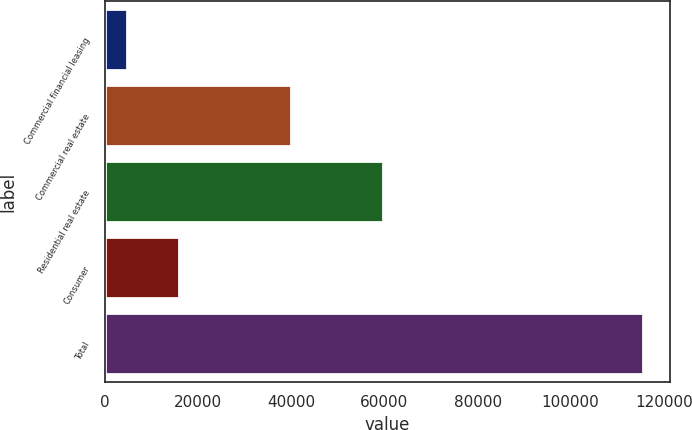Convert chart to OTSL. <chart><loc_0><loc_0><loc_500><loc_500><bar_chart><fcel>Commercial financial leasing<fcel>Commercial real estate<fcel>Residential real estate<fcel>Consumer<fcel>Total<nl><fcel>4794<fcel>39867<fcel>59657<fcel>15873.9<fcel>115593<nl></chart> 